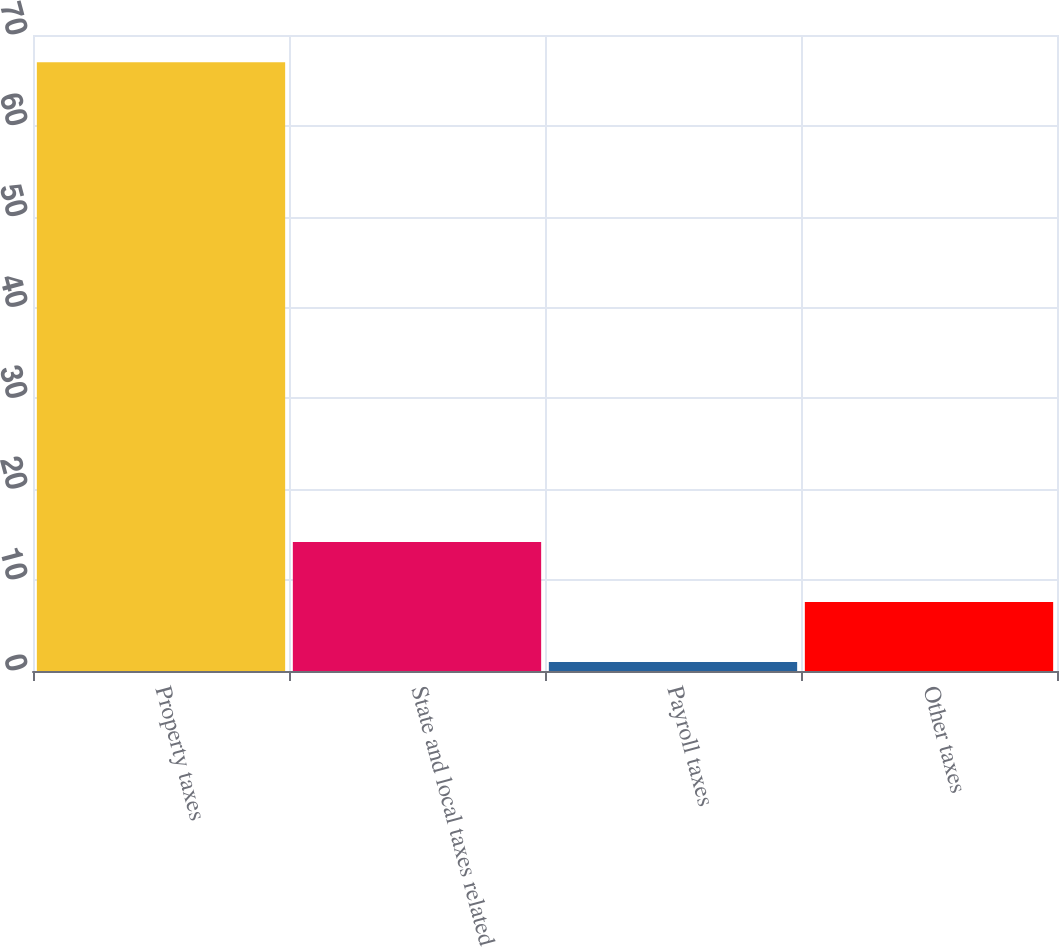Convert chart. <chart><loc_0><loc_0><loc_500><loc_500><bar_chart><fcel>Property taxes<fcel>State and local taxes related<fcel>Payroll taxes<fcel>Other taxes<nl><fcel>67<fcel>14.2<fcel>1<fcel>7.6<nl></chart> 